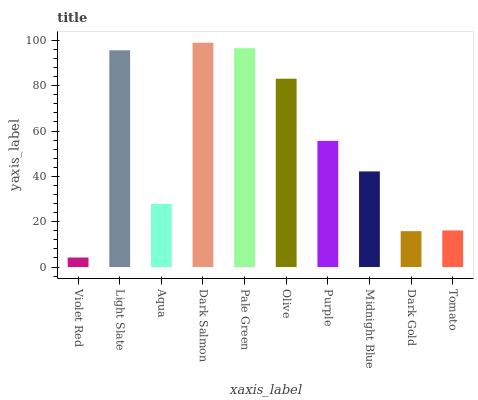Is Violet Red the minimum?
Answer yes or no. Yes. Is Dark Salmon the maximum?
Answer yes or no. Yes. Is Light Slate the minimum?
Answer yes or no. No. Is Light Slate the maximum?
Answer yes or no. No. Is Light Slate greater than Violet Red?
Answer yes or no. Yes. Is Violet Red less than Light Slate?
Answer yes or no. Yes. Is Violet Red greater than Light Slate?
Answer yes or no. No. Is Light Slate less than Violet Red?
Answer yes or no. No. Is Purple the high median?
Answer yes or no. Yes. Is Midnight Blue the low median?
Answer yes or no. Yes. Is Light Slate the high median?
Answer yes or no. No. Is Dark Gold the low median?
Answer yes or no. No. 